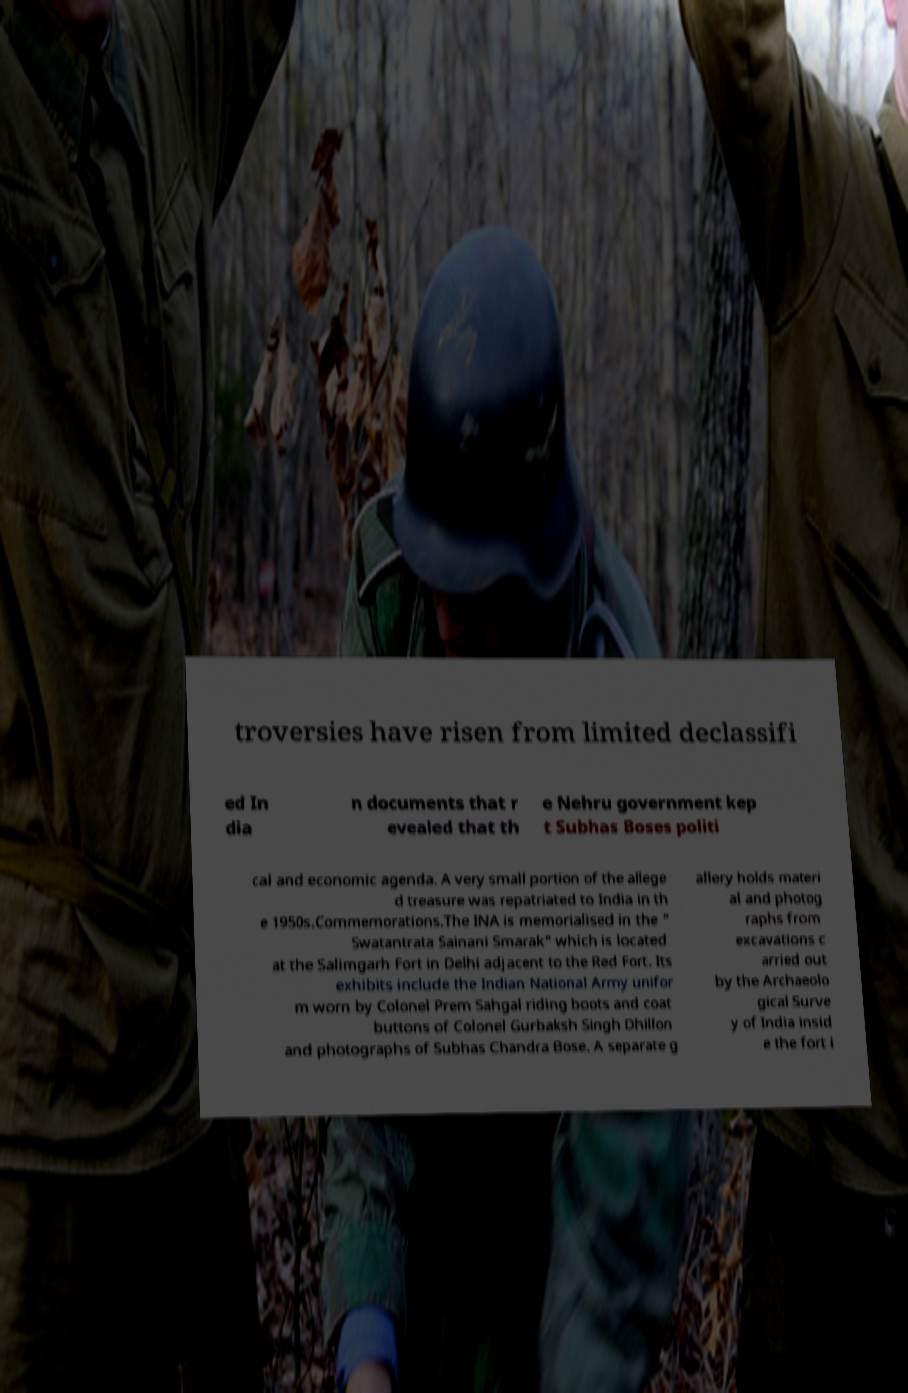Could you assist in decoding the text presented in this image and type it out clearly? troversies have risen from limited declassifi ed In dia n documents that r evealed that th e Nehru government kep t Subhas Boses politi cal and economic agenda. A very small portion of the allege d treasure was repatriated to India in th e 1950s.Commemorations.The INA is memorialised in the " Swatantrata Sainani Smarak" which is located at the Salimgarh Fort in Delhi adjacent to the Red Fort. Its exhibits include the Indian National Army unifor m worn by Colonel Prem Sahgal riding boots and coat buttons of Colonel Gurbaksh Singh Dhillon and photographs of Subhas Chandra Bose. A separate g allery holds materi al and photog raphs from excavations c arried out by the Archaeolo gical Surve y of India insid e the fort i 